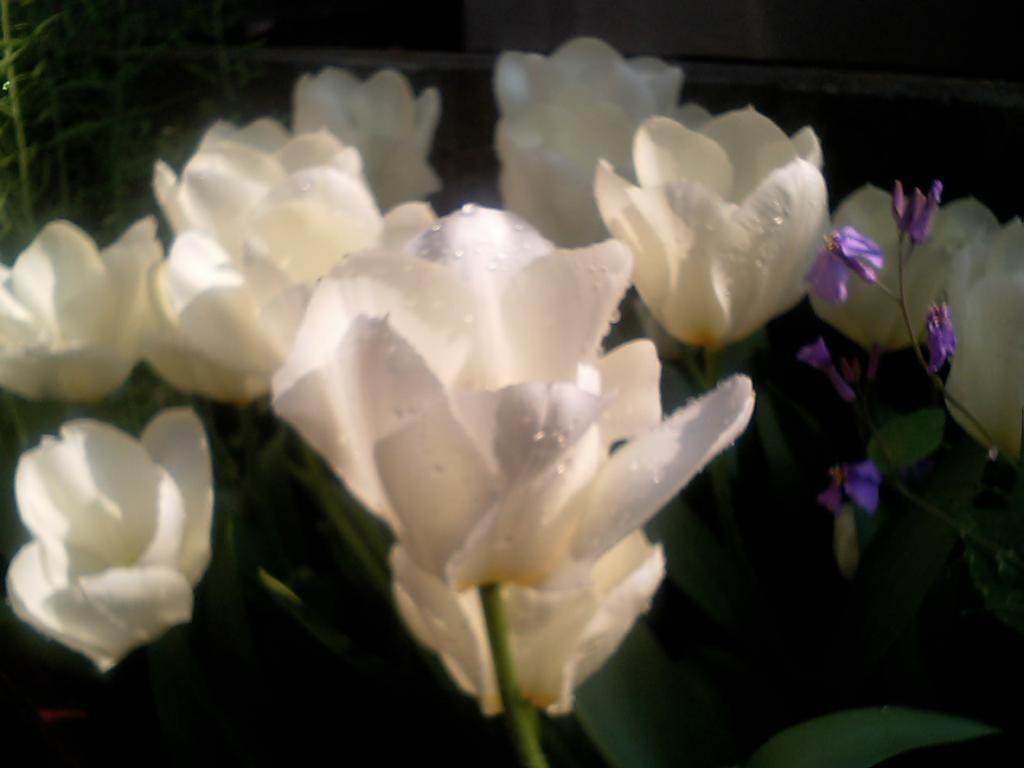How would you summarize this image in a sentence or two? In this image we can see some plants with white and purple color flowers, in the background, we can see a building and the wall. 